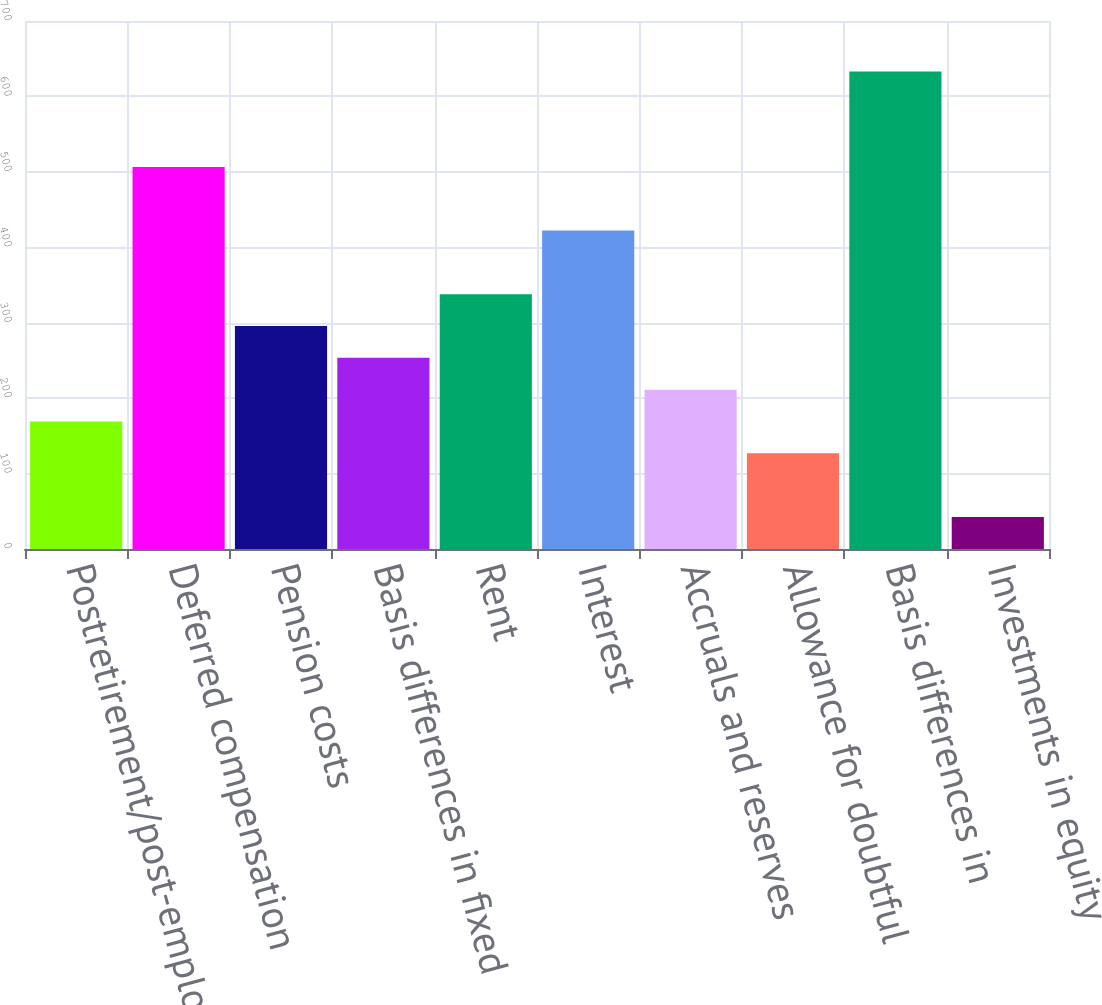Convert chart. <chart><loc_0><loc_0><loc_500><loc_500><bar_chart><fcel>Postretirement/post-employment<fcel>Deferred compensation<fcel>Pension costs<fcel>Basis differences in fixed<fcel>Rent<fcel>Interest<fcel>Accruals and reserves<fcel>Allowance for doubtful<fcel>Basis differences in<fcel>Investments in equity<nl><fcel>169.06<fcel>506.58<fcel>295.63<fcel>253.44<fcel>337.82<fcel>422.2<fcel>211.25<fcel>126.87<fcel>633.15<fcel>42.49<nl></chart> 